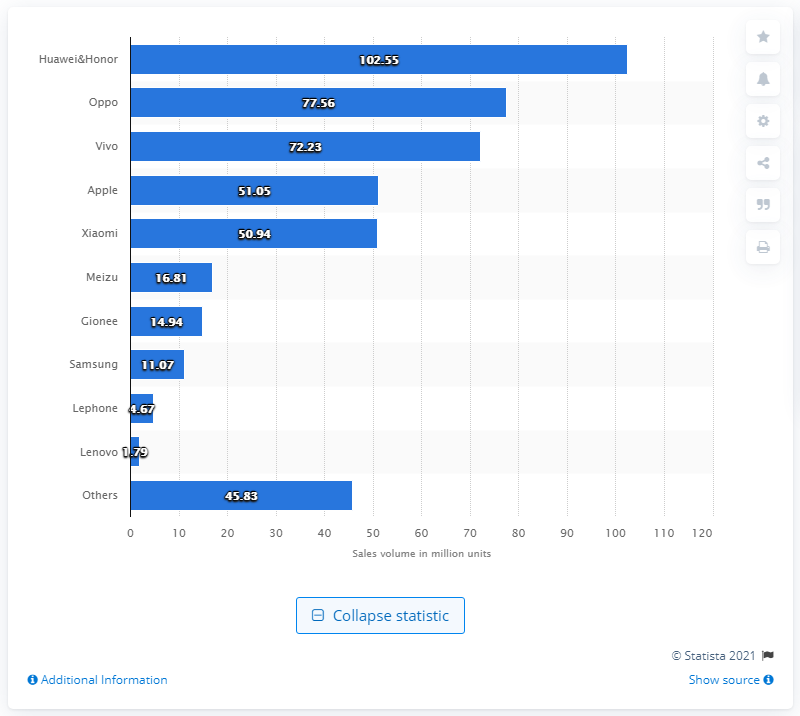List a handful of essential elements in this visual. Oppo sold 77.56 million smartphones in China in 2017, making it the company that sold the most smartphones in China that year. Oppo sold 77.56 million smartphones in China in 2017. 